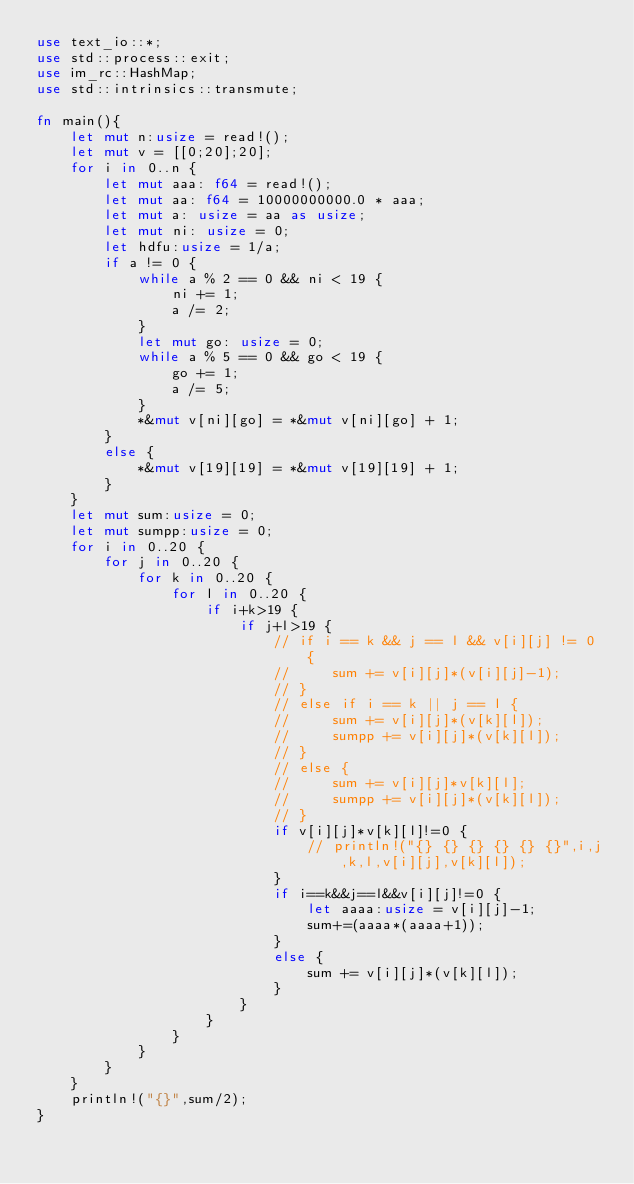Convert code to text. <code><loc_0><loc_0><loc_500><loc_500><_Rust_>use text_io::*;
use std::process::exit;
use im_rc::HashMap;
use std::intrinsics::transmute;

fn main(){
    let mut n:usize = read!();
    let mut v = [[0;20];20];
    for i in 0..n {
        let mut aaa: f64 = read!();
        let mut aa: f64 = 10000000000.0 * aaa;
        let mut a: usize = aa as usize;
        let mut ni: usize = 0;
        let hdfu:usize = 1/a;
        if a != 0 {
            while a % 2 == 0 && ni < 19 {
                ni += 1;
                a /= 2;
            }
            let mut go: usize = 0;
            while a % 5 == 0 && go < 19 {
                go += 1;
                a /= 5;
            }
            *&mut v[ni][go] = *&mut v[ni][go] + 1;
        }
        else {
            *&mut v[19][19] = *&mut v[19][19] + 1;
        }
    }
    let mut sum:usize = 0;
    let mut sumpp:usize = 0;
    for i in 0..20 {
        for j in 0..20 {
            for k in 0..20 {
                for l in 0..20 {
                    if i+k>19 {
                        if j+l>19 {
                            // if i == k && j == l && v[i][j] != 0 {
                            //     sum += v[i][j]*(v[i][j]-1);
                            // }
                            // else if i == k || j == l {
                            //     sum += v[i][j]*(v[k][l]);
                            //     sumpp += v[i][j]*(v[k][l]);
                            // }
                            // else {
                            //     sum += v[i][j]*v[k][l];
                            //     sumpp += v[i][j]*(v[k][l]);
                            // }
                            if v[i][j]*v[k][l]!=0 {
                                // println!("{} {} {} {} {} {}",i,j,k,l,v[i][j],v[k][l]);
                            }
                            if i==k&&j==l&&v[i][j]!=0 {
                                let aaaa:usize = v[i][j]-1;
                                sum+=(aaaa*(aaaa+1));
                            }
                            else {
                                sum += v[i][j]*(v[k][l]);
                            }
                        }
                    }
                }
            }
        }
    }
    println!("{}",sum/2);
}</code> 